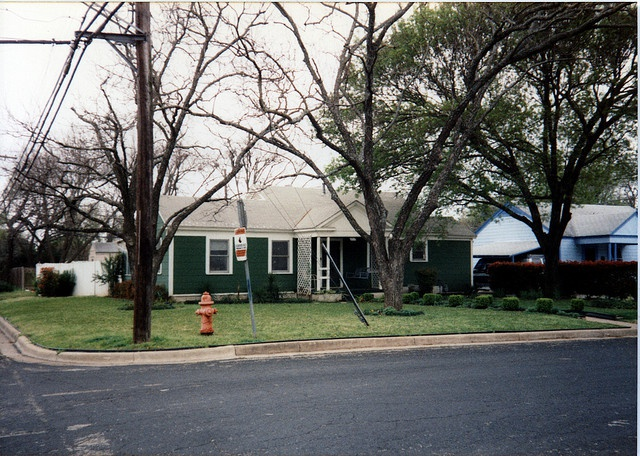Describe the objects in this image and their specific colors. I can see a fire hydrant in white, salmon, brown, maroon, and tan tones in this image. 